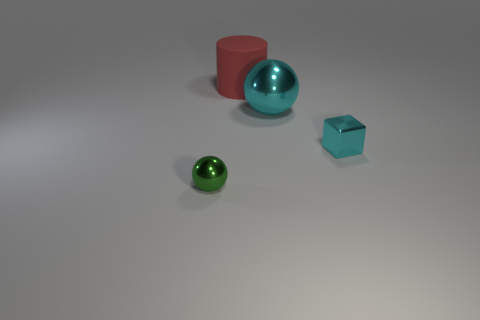There is a small metallic thing on the right side of the big ball; is it the same color as the metallic sphere to the right of the green metal object?
Give a very brief answer. Yes. There is a shiny object that is the same color as the large metal ball; what size is it?
Make the answer very short. Small. The object that is the same size as the cyan metallic block is what color?
Offer a very short reply. Green. There is a cyan metal block; is its size the same as the thing in front of the tiny shiny cube?
Your answer should be compact. Yes. What number of shiny spheres are the same color as the tiny block?
Offer a very short reply. 1. How many objects are either cyan rubber cubes or balls that are on the right side of the cylinder?
Make the answer very short. 1. There is a thing that is behind the large shiny ball; is it the same size as the object that is on the left side of the large matte object?
Ensure brevity in your answer.  No. Is there another ball that has the same material as the big sphere?
Provide a short and direct response. Yes. What is the shape of the large metallic thing?
Provide a short and direct response. Sphere. There is a tiny metal thing to the left of the tiny metallic object behind the green metallic ball; what is its shape?
Provide a succinct answer. Sphere. 